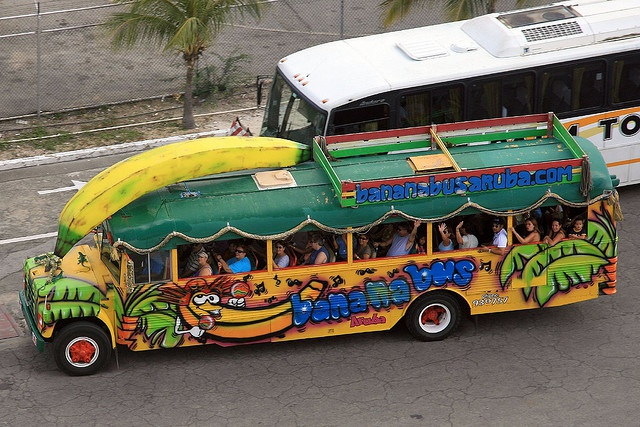Describe the objects in this image and their specific colors. I can see bus in gray, black, teal, and orange tones, bus in gray, white, black, and darkgray tones, banana in gray, khaki, gold, and olive tones, people in gray, black, brown, and maroon tones, and people in gray, black, purple, and maroon tones in this image. 